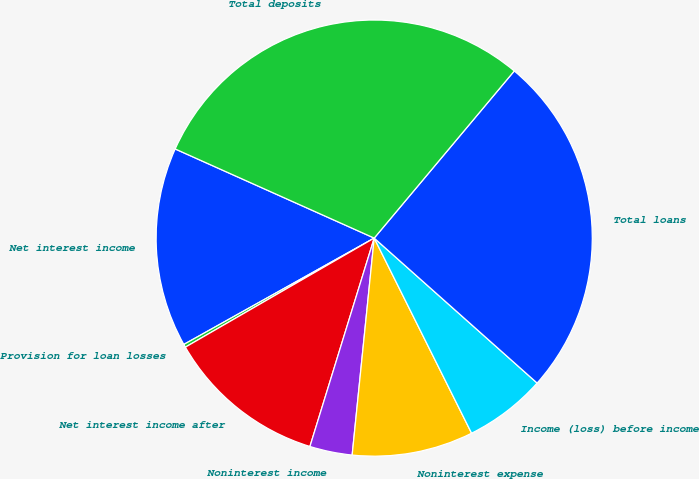Convert chart. <chart><loc_0><loc_0><loc_500><loc_500><pie_chart><fcel>Net interest income<fcel>Provision for loan losses<fcel>Net interest income after<fcel>Noninterest income<fcel>Noninterest expense<fcel>Income (loss) before income<fcel>Total loans<fcel>Total deposits<nl><fcel>14.81%<fcel>0.23%<fcel>11.9%<fcel>3.15%<fcel>8.98%<fcel>6.06%<fcel>25.47%<fcel>29.4%<nl></chart> 